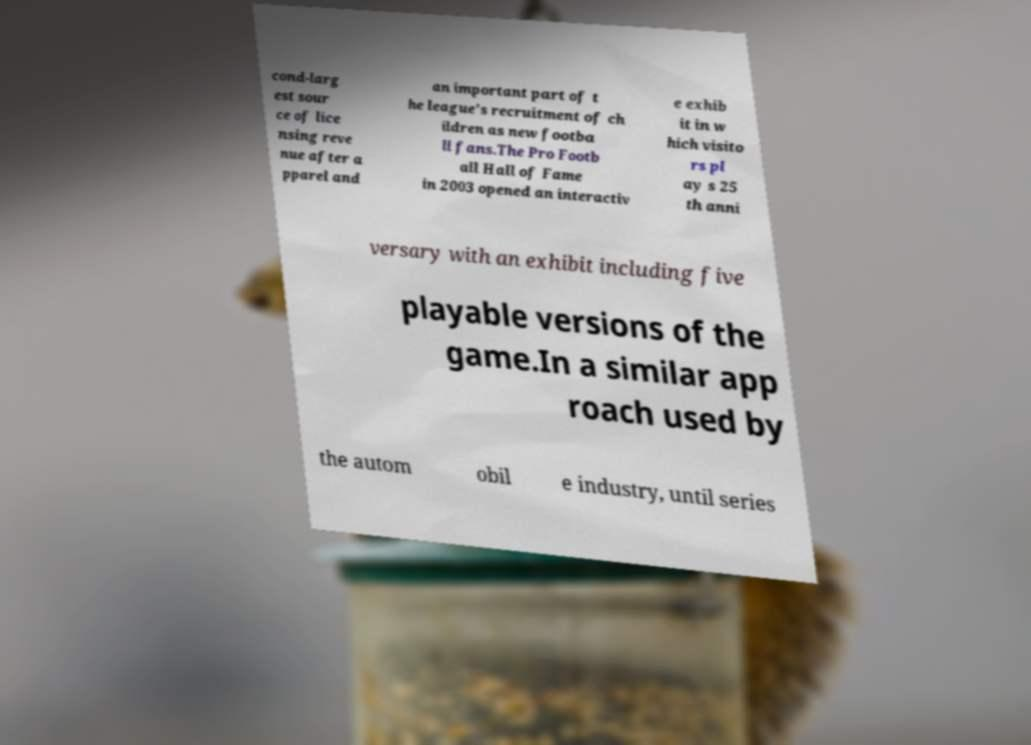What messages or text are displayed in this image? I need them in a readable, typed format. cond-larg est sour ce of lice nsing reve nue after a pparel and an important part of t he league's recruitment of ch ildren as new footba ll fans.The Pro Footb all Hall of Fame in 2003 opened an interactiv e exhib it in w hich visito rs pl ay s 25 th anni versary with an exhibit including five playable versions of the game.In a similar app roach used by the autom obil e industry, until series 